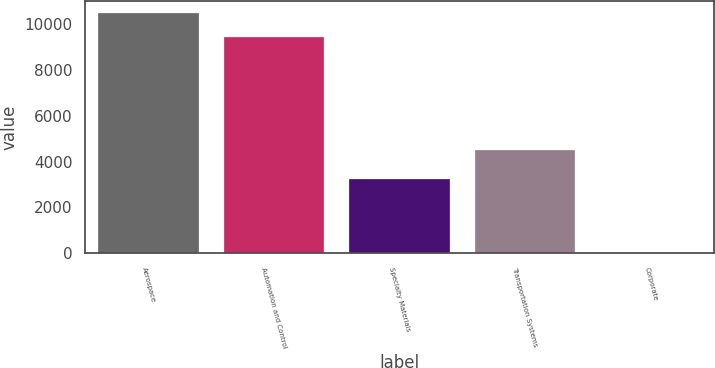Convert chart. <chart><loc_0><loc_0><loc_500><loc_500><bar_chart><fcel>Aerospace<fcel>Automation and Control<fcel>Specialty Materials<fcel>Transportation Systems<fcel>Corporate<nl><fcel>10497<fcel>9416<fcel>3234<fcel>4505<fcel>1<nl></chart> 